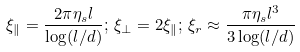Convert formula to latex. <formula><loc_0><loc_0><loc_500><loc_500>\xi _ { \| } = \frac { 2 \pi \eta _ { s } l } { \log ( l / d ) } ; \, \xi _ { \perp } = 2 \xi _ { \| } ; \, \xi _ { r } \approx \frac { \pi \eta _ { s } l ^ { 3 } } { 3 \log ( l / d ) }</formula> 